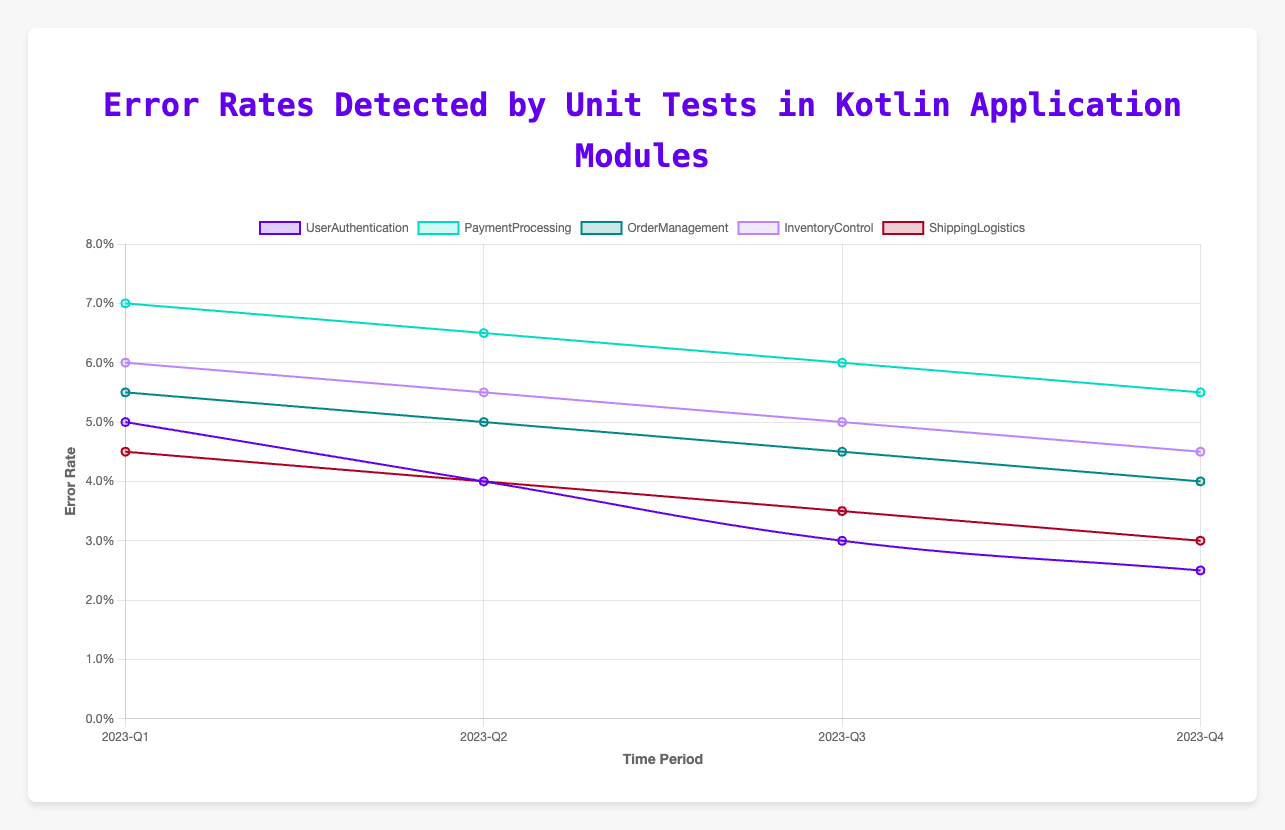Which module had the highest error rate in 2023-Q1? Look at the error rates for each module in 2023-Q1. The PaymentProcessing module has the highest error rate of 0.07.
Answer: PaymentProcessing Which module showed the greatest improvement in error rates from 2023-Q1 to 2023-Q4? Calculate the difference in error rates for each module between 2023-Q1 and 2023-Q4. The UserAuthentication module shows the biggest improvement with a reduction of 0.05 - 0.025 = 0.025.
Answer: UserAuthentication What is the average error rate for the OrderManagement module across all quarters? Add up the error rates for OrderManagement across all quarters and divide by the total number of quarters: (0.055 + 0.05 + 0.045 + 0.04) / 4 = 0.0475.
Answer: 0.0475 Compare the error rates of InventoryControl and PaymentProcessing in 2023-Q2. Which one is higher? Compare the error rates of InventoryControl and PaymentProcessing in 2023-Q2 which are 0.055 and 0.065 respectively. The PaymentProcessing module has a higher error rate in 2023-Q2.
Answer: PaymentProcessing Which module has consistently shown a decrease in error rates across all quarters? Check the trend for each module's error rates across all quarters to see if it continuously decreases. The UserAuthentication module shows consistent decreases in error rates in every quarter.
Answer: UserAuthentication How much did the error rate for ShippingLogistics decrease from 2023-Q2 to 2023-Q3? Subtract the error rate in 2023-Q3 from 2023-Q2 for the ShippingLogistics module: 0.04 - 0.035 = 0.005.
Answer: 0.005 Which module had the lowest error rate in 2023-Q4? Compare the error rates of all modules in 2023-Q4. The UserAuthentication module has the lowest error rate of 0.025 in 2023-Q4.
Answer: UserAuthentication What was the total decrease in error rate for the PaymentProcessing module from 2023-Q1 to 2023-Q4? Subtract the error rate in 2023-Q4 from 2023-Q1 for the PaymentProcessing module: 0.07 - 0.055 = 0.015.
Answer: 0.015 Looking at visual attributes, which line on the chart is represented with the color closest to purple? Use the color representation in the chart. The UserAuthentication module is represented with the color closest to purple.
Answer: UserAuthentication For the InventoryControl module, what was the error rate change between each consecutive quarter? Calculate the differences between each consecutive quarter for InventoryControl: from Q1 to Q2 (0.06 - 0.055 = 0.005), from Q2 to Q3 (0.055 - 0.05 = 0.005), from Q3 to Q4 (0.05 - 0.045 = 0.005).
Answer: 0.005 for each quarter 